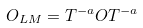Convert formula to latex. <formula><loc_0><loc_0><loc_500><loc_500>O _ { L M } = T ^ { - a } O T ^ { - a }</formula> 